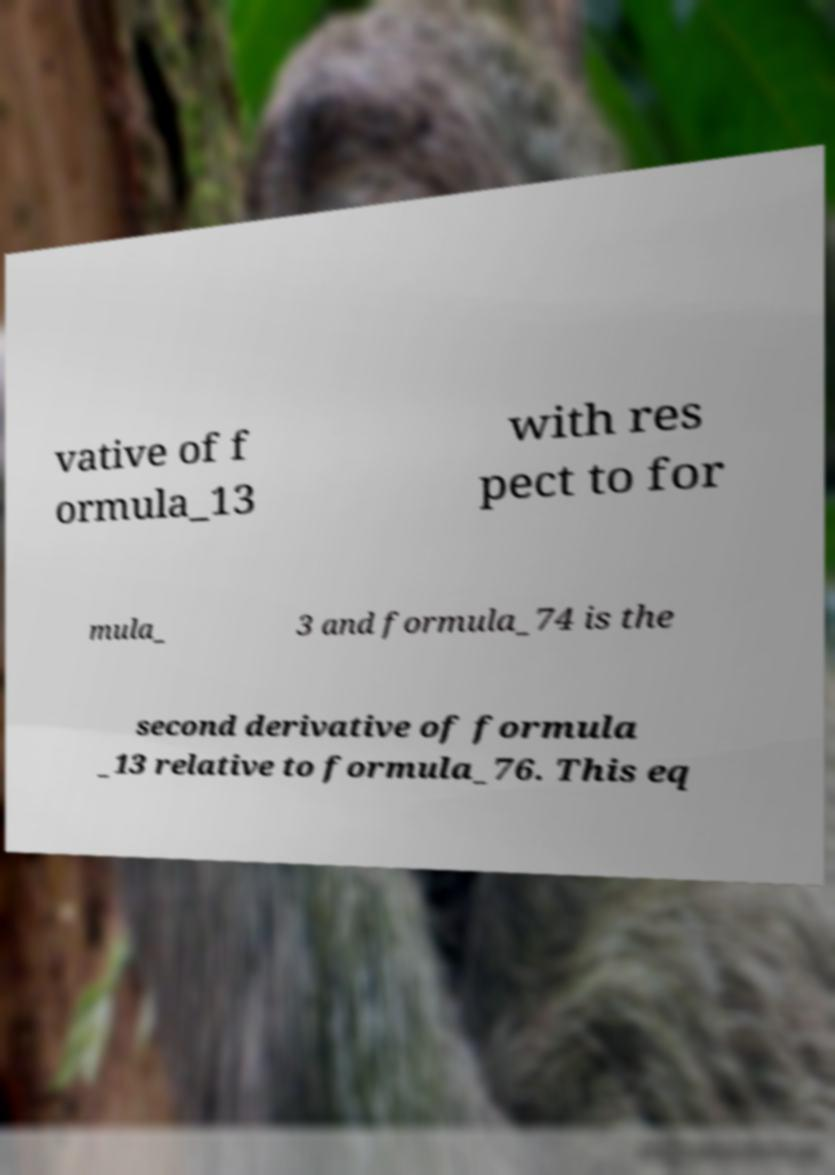Could you extract and type out the text from this image? vative of f ormula_13 with res pect to for mula_ 3 and formula_74 is the second derivative of formula _13 relative to formula_76. This eq 